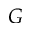<formula> <loc_0><loc_0><loc_500><loc_500>G</formula> 